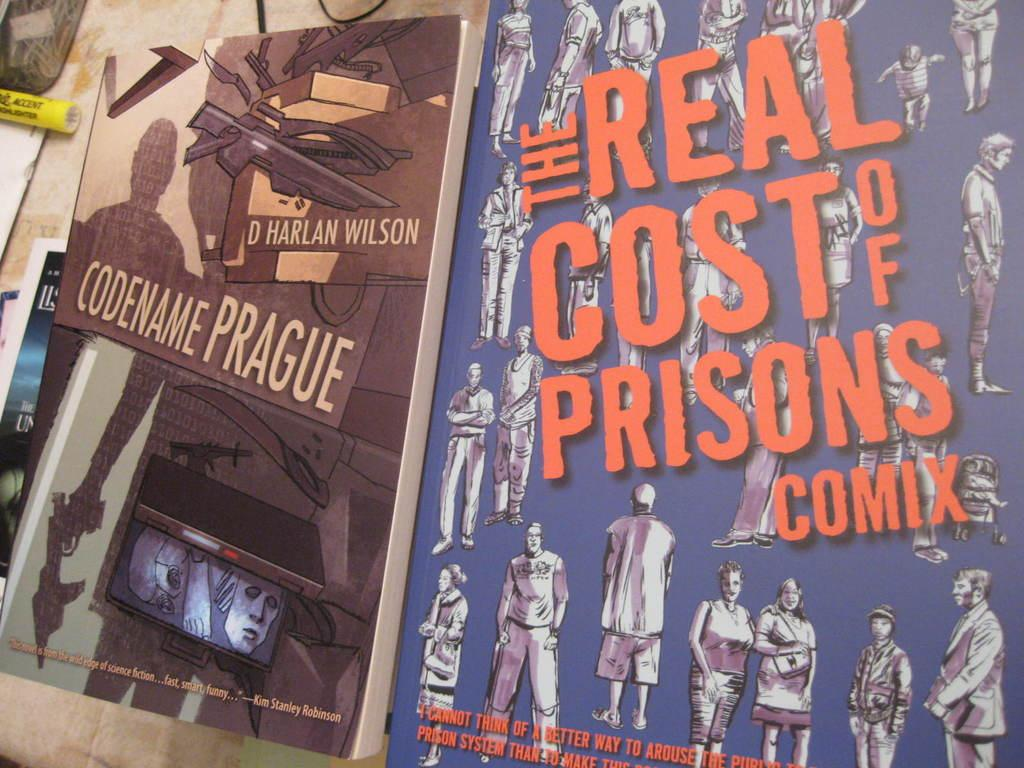<image>
Offer a succinct explanation of the picture presented. Two posters are displayed featuring "Codename Prague" and "The real cost of prisons comix". 